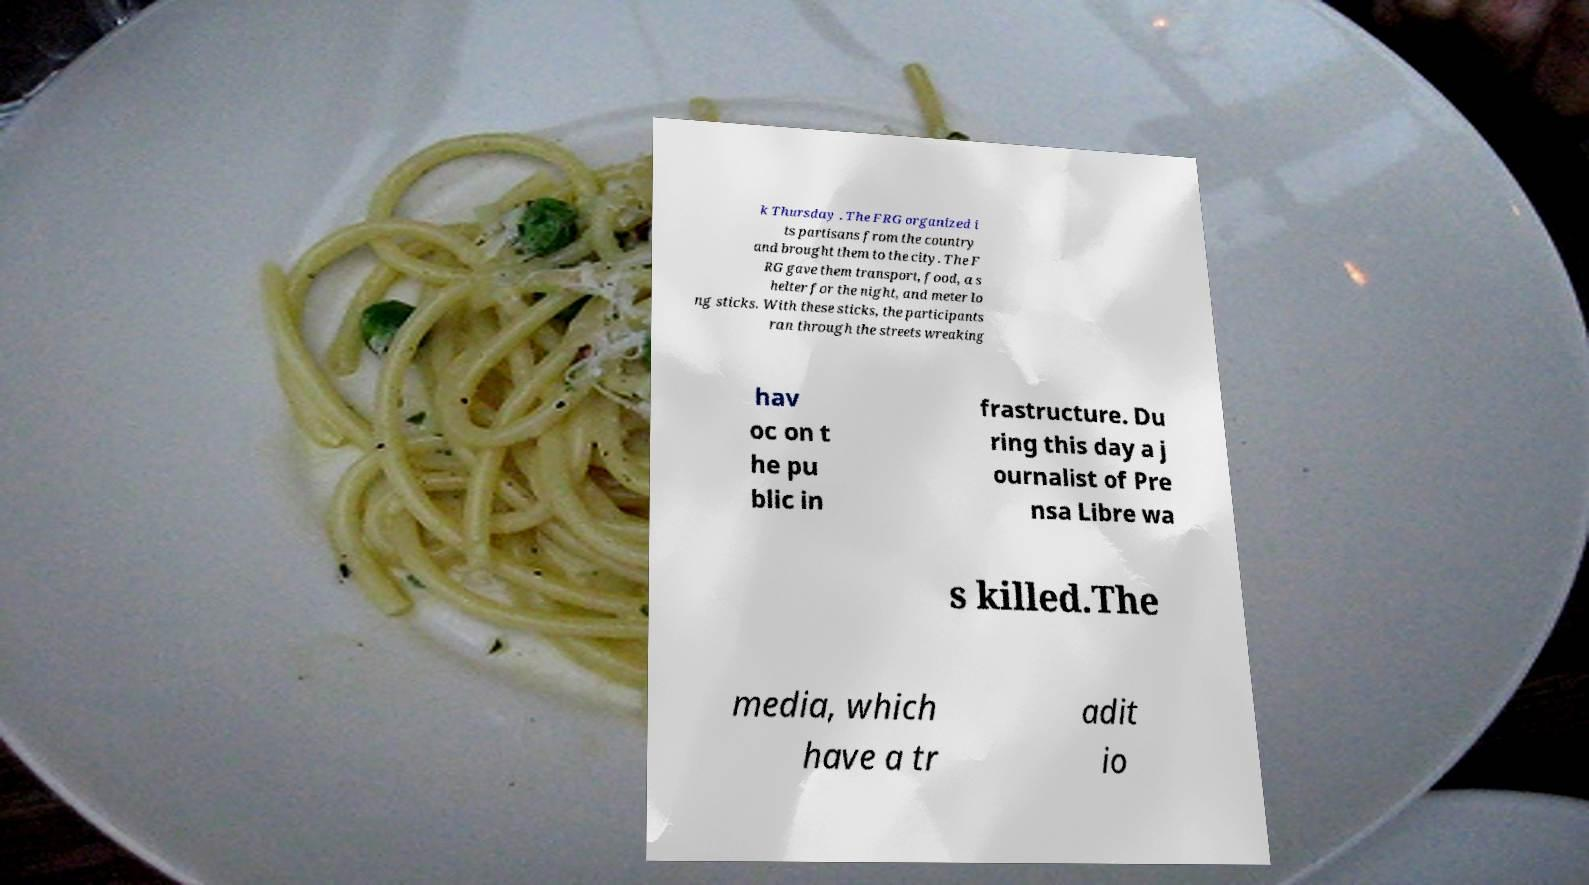For documentation purposes, I need the text within this image transcribed. Could you provide that? k Thursday . The FRG organized i ts partisans from the country and brought them to the city. The F RG gave them transport, food, a s helter for the night, and meter lo ng sticks. With these sticks, the participants ran through the streets wreaking hav oc on t he pu blic in frastructure. Du ring this day a j ournalist of Pre nsa Libre wa s killed.The media, which have a tr adit io 